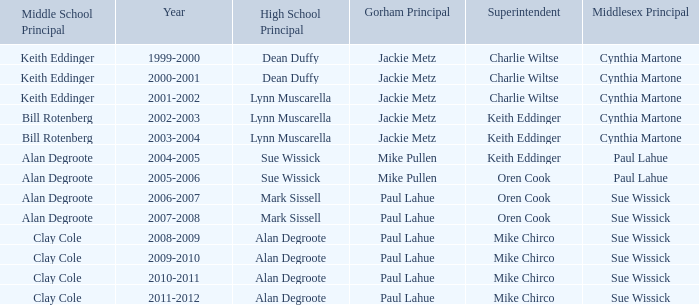Who were the middle school principal(s) in 2010-2011? Clay Cole. 